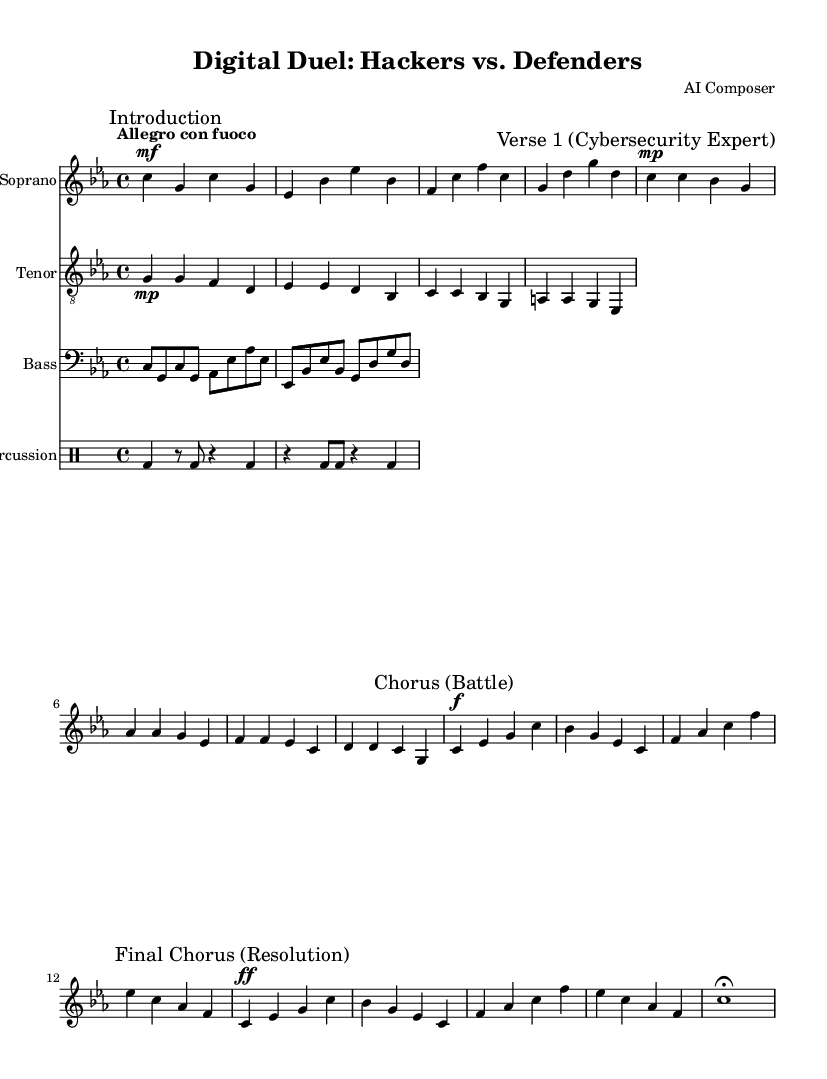What is the key signature of this music? The key signature is indicated at the beginning of the score, which shows three flats. This corresponds to the key of C minor.
Answer: C minor What is the time signature of this music? The time signature is indicated after the key signature and shows 4 over 4, which means there are four beats in a measure and a quarter note gets one beat.
Answer: 4/4 What is the tempo marking for this piece? The tempo marking is located at the start of the score, showing "Allegro con fuoco," which indicates the piece should be played at a quick pace with fire or passion.
Answer: Allegro con fuoco How many verses are there in the opera? The score contains two verses, as indicated by the markings in the soprano and tenor parts, showing a distinction between Cybersecurity Expert and Hacker roles.
Answer: 2 What instrument accompanies the soprano? The soprano is accompanied by a staff labeled as "Bass," which provides harmonic support in the piece, indicated within the score layout.
Answer: Bass What is the theme of the chorus in this opera? The chorus sections of the opera highlight the conflict between hackers and defenders, specifically referencing the "Clash of titans in the network," which reflects the central battle theme.
Answer: Battle What is the dynamic marking for the final chorus? The final chorus has a dynamic marking of "ff," indicating a very loud volume is to be used as the conflict reaches its resolution.
Answer: ff 